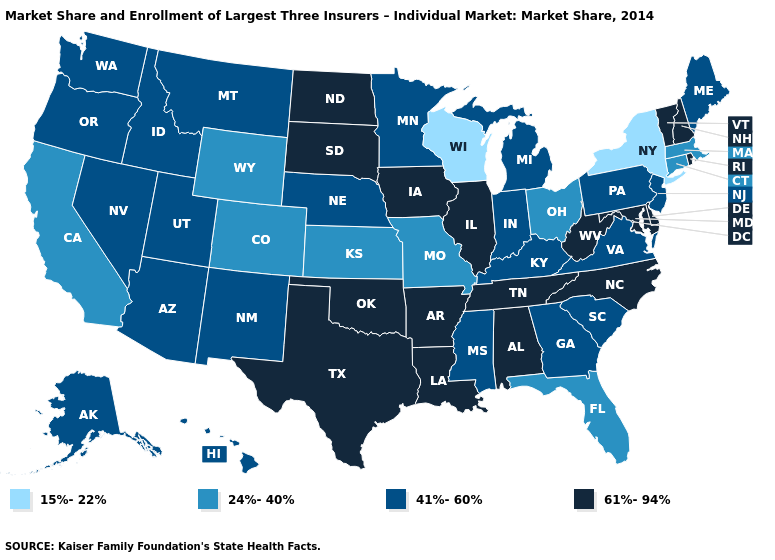What is the value of North Carolina?
Short answer required. 61%-94%. Name the states that have a value in the range 61%-94%?
Concise answer only. Alabama, Arkansas, Delaware, Illinois, Iowa, Louisiana, Maryland, New Hampshire, North Carolina, North Dakota, Oklahoma, Rhode Island, South Dakota, Tennessee, Texas, Vermont, West Virginia. Name the states that have a value in the range 41%-60%?
Keep it brief. Alaska, Arizona, Georgia, Hawaii, Idaho, Indiana, Kentucky, Maine, Michigan, Minnesota, Mississippi, Montana, Nebraska, Nevada, New Jersey, New Mexico, Oregon, Pennsylvania, South Carolina, Utah, Virginia, Washington. What is the lowest value in states that border Nevada?
Concise answer only. 24%-40%. Name the states that have a value in the range 15%-22%?
Keep it brief. New York, Wisconsin. What is the highest value in the USA?
Keep it brief. 61%-94%. Among the states that border South Dakota , which have the lowest value?
Short answer required. Wyoming. Does Florida have the lowest value in the South?
Be succinct. Yes. Name the states that have a value in the range 61%-94%?
Quick response, please. Alabama, Arkansas, Delaware, Illinois, Iowa, Louisiana, Maryland, New Hampshire, North Carolina, North Dakota, Oklahoma, Rhode Island, South Dakota, Tennessee, Texas, Vermont, West Virginia. Which states hav the highest value in the Northeast?
Keep it brief. New Hampshire, Rhode Island, Vermont. Among the states that border Maine , which have the highest value?
Quick response, please. New Hampshire. Which states have the highest value in the USA?
Short answer required. Alabama, Arkansas, Delaware, Illinois, Iowa, Louisiana, Maryland, New Hampshire, North Carolina, North Dakota, Oklahoma, Rhode Island, South Dakota, Tennessee, Texas, Vermont, West Virginia. How many symbols are there in the legend?
Be succinct. 4. Which states have the lowest value in the USA?
Keep it brief. New York, Wisconsin. 